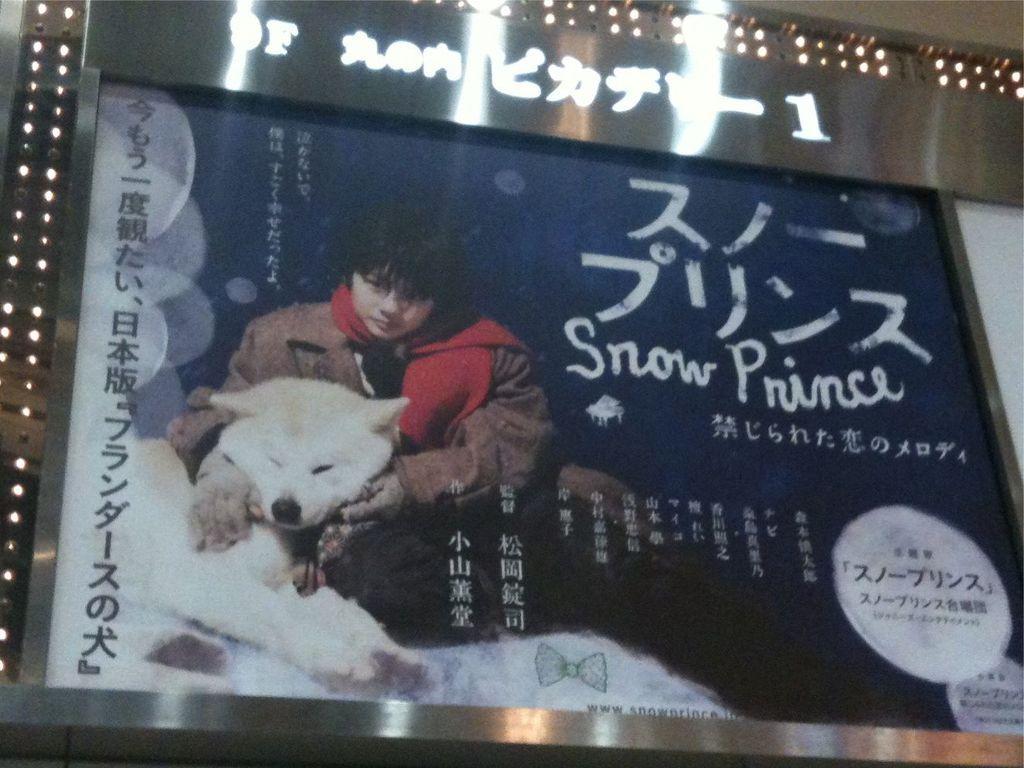Can you describe this image briefly? In the picture we can see a hoarding with some painting of and an image of a boy holding a dog which is white in color and beside it is written as snow prince and in the background we can see some flashlights. 